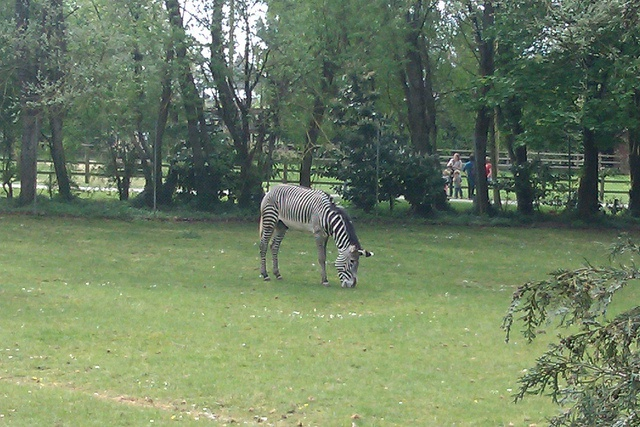Describe the objects in this image and their specific colors. I can see zebra in gray, darkgray, black, and lightgray tones, people in gray, darkgray, and black tones, people in gray, blue, darkblue, and black tones, people in gray, darkgray, darkblue, and purple tones, and people in gray, brown, darkgray, and maroon tones in this image. 